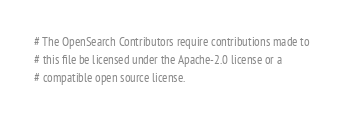<code> <loc_0><loc_0><loc_500><loc_500><_Python_># The OpenSearch Contributors require contributions made to
# this file be licensed under the Apache-2.0 license or a
# compatible open source license.
</code> 